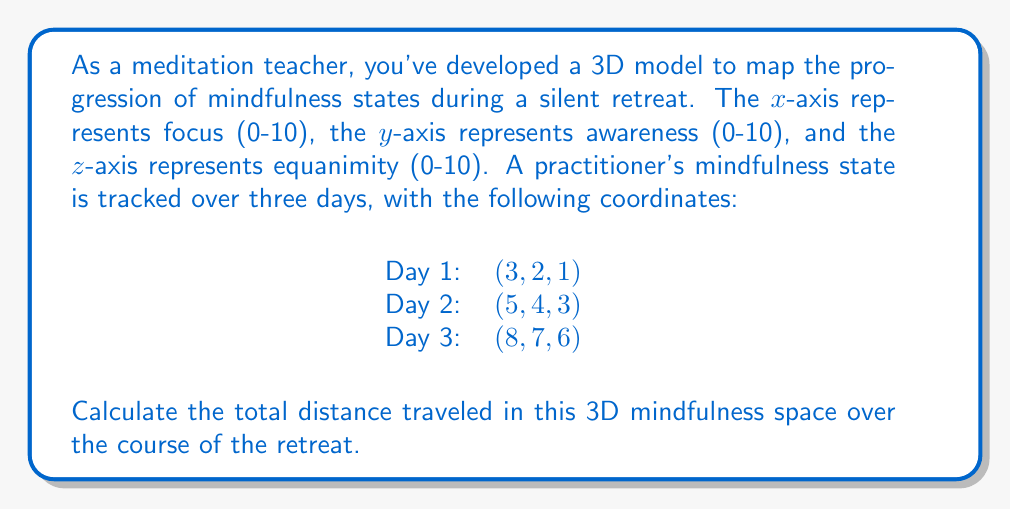Help me with this question. To solve this problem, we need to calculate the distance between each pair of consecutive points and then sum these distances. We can use the 3D distance formula, which is an extension of the Pythagorean theorem to three dimensions.

The 3D distance formula between two points $(x_1, y_1, z_1)$ and $(x_2, y_2, z_2)$ is:

$$d = \sqrt{(x_2-x_1)^2 + (y_2-y_1)^2 + (z_2-z_1)^2}$$

Let's calculate the distance for each day:

1. Distance from Day 1 to Day 2:
   $d_1 = \sqrt{(5-3)^2 + (4-2)^2 + (3-1)^2}$
   $d_1 = \sqrt{2^2 + 2^2 + 2^2} = \sqrt{4 + 4 + 4} = \sqrt{12} = 2\sqrt{3}$

2. Distance from Day 2 to Day 3:
   $d_2 = \sqrt{(8-5)^2 + (7-4)^2 + (6-3)^2}$
   $d_2 = \sqrt{3^2 + 3^2 + 3^2} = \sqrt{9 + 9 + 9} = \sqrt{27} = 3\sqrt{3}$

Now, we sum these distances to get the total distance traveled:

Total distance = $d_1 + d_2 = 2\sqrt{3} + 3\sqrt{3} = 5\sqrt{3}$
Answer: $5\sqrt{3}$ units 